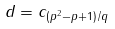Convert formula to latex. <formula><loc_0><loc_0><loc_500><loc_500>d = c _ { ( p ^ { 2 } - p + 1 ) / q }</formula> 